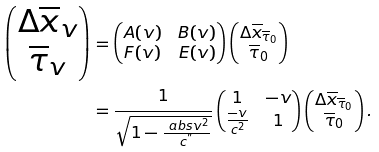<formula> <loc_0><loc_0><loc_500><loc_500>\begin{pmatrix} \Delta \overline { x } _ { v } \\ \overline { \tau } _ { v } \end{pmatrix} & = \begin{pmatrix} A ( v ) & B ( v ) \\ F ( v ) & E ( v ) \end{pmatrix} \begin{pmatrix} \Delta \overline { x } _ { \overline { \tau } _ { 0 } } \\ \overline { \tau } _ { 0 } \end{pmatrix} \\ & = \frac { 1 } { \sqrt { 1 - \frac { \ a b s { v } ^ { 2 } } { c ^ { " } } } } \begin{pmatrix} 1 & - v \\ \frac { - v } { c ^ { 2 } } & 1 \end{pmatrix} \begin{pmatrix} \Delta \overline { x } _ { \overline { \tau } _ { 0 } } \\ \overline { \tau } _ { 0 } \end{pmatrix} .</formula> 